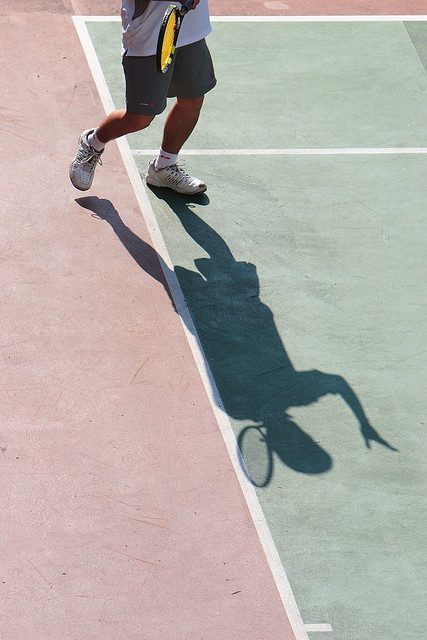Describe the objects in this image and their specific colors. I can see people in lightpink, black, gray, and maroon tones and tennis racket in lightpink, orange, black, and olive tones in this image. 